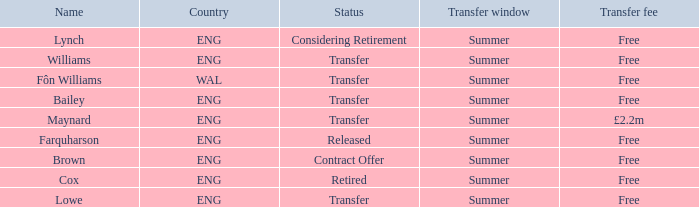In the context of an eng country and a transfer status, what is the term for the free transfer fee? Bailey, Williams, Lowe. 